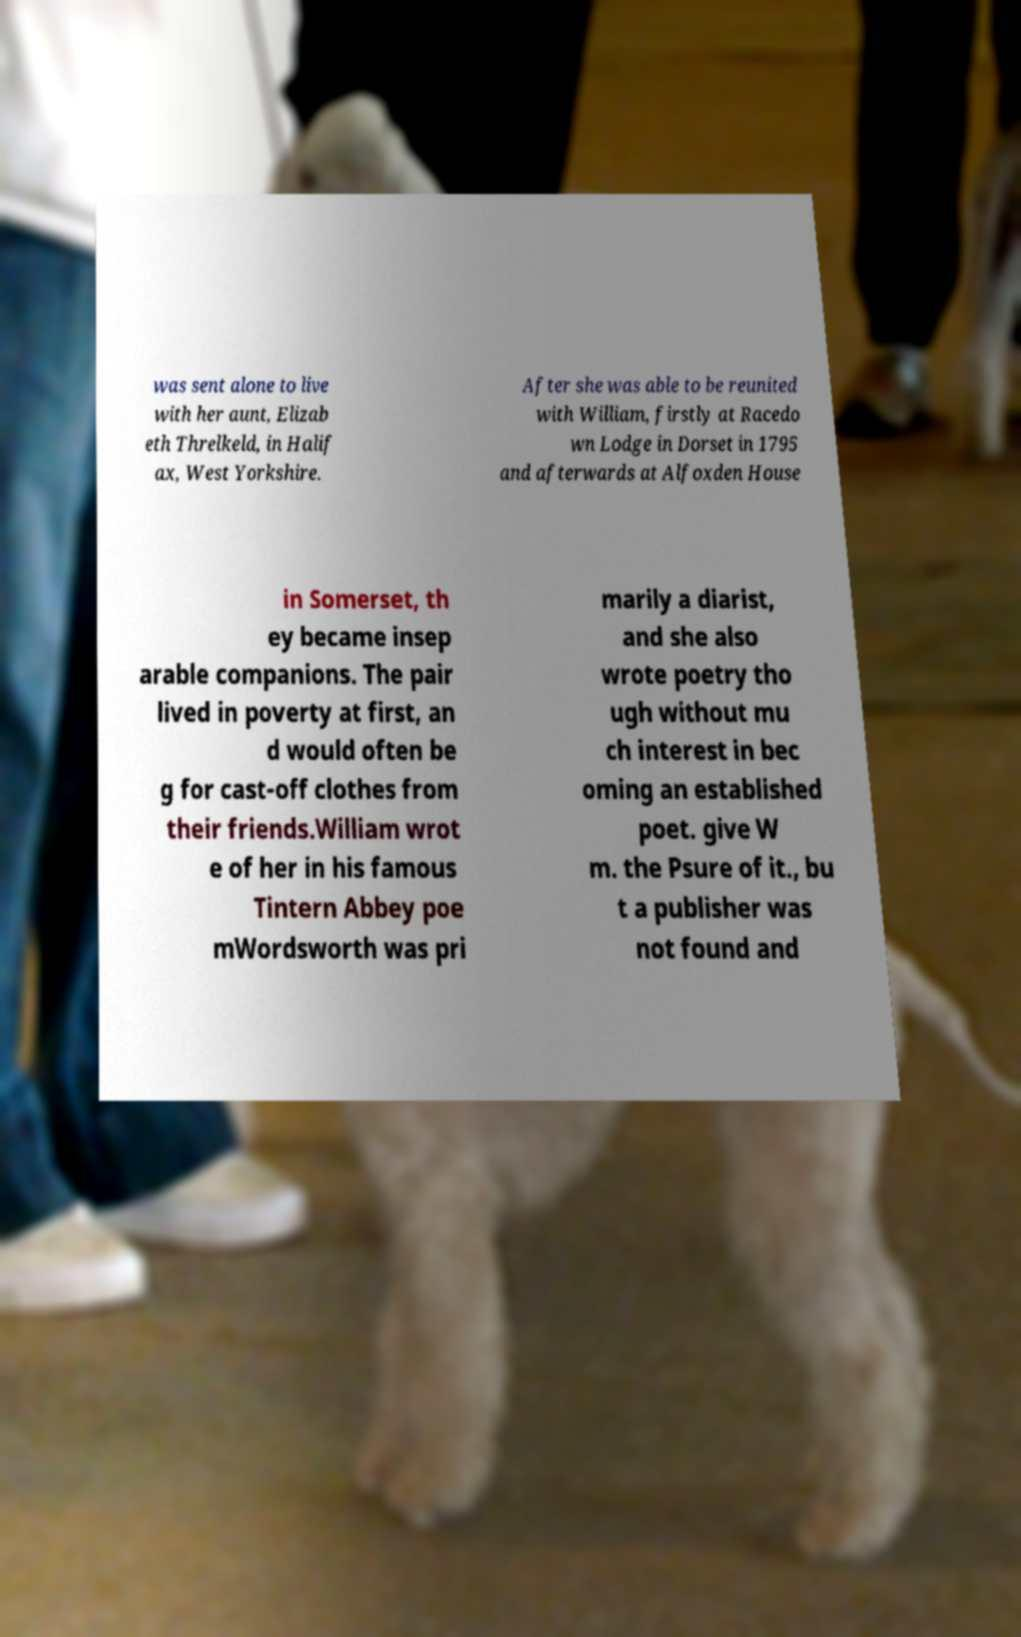Please identify and transcribe the text found in this image. was sent alone to live with her aunt, Elizab eth Threlkeld, in Halif ax, West Yorkshire. After she was able to be reunited with William, firstly at Racedo wn Lodge in Dorset in 1795 and afterwards at Alfoxden House in Somerset, th ey became insep arable companions. The pair lived in poverty at first, an d would often be g for cast-off clothes from their friends.William wrot e of her in his famous Tintern Abbey poe mWordsworth was pri marily a diarist, and she also wrote poetry tho ugh without mu ch interest in bec oming an established poet. give W m. the Psure of it., bu t a publisher was not found and 